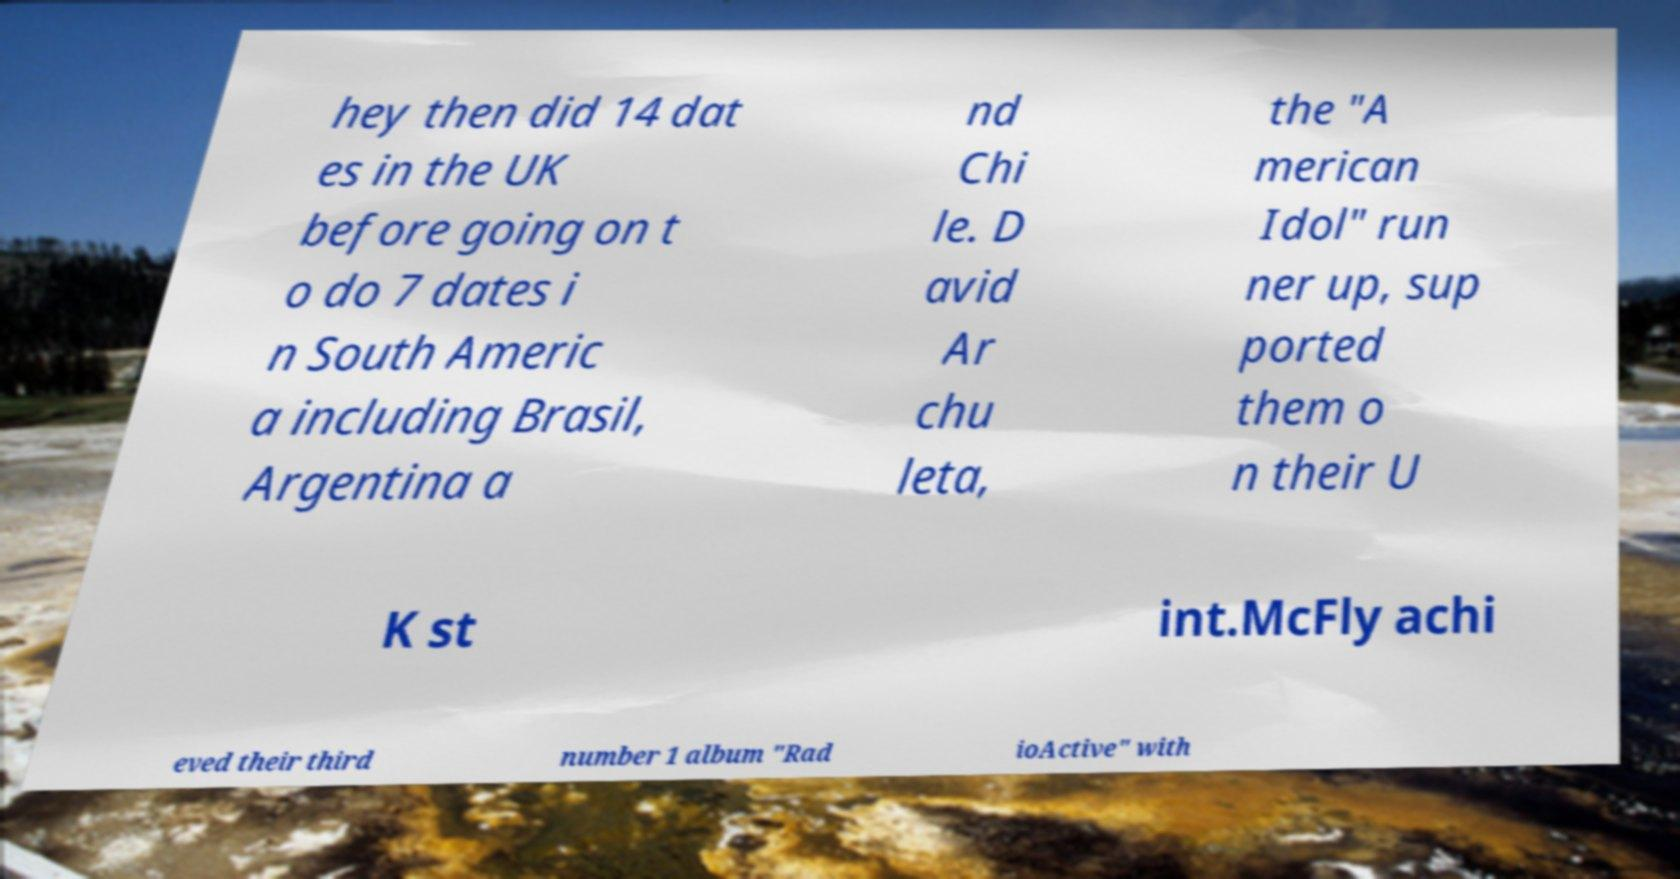Please read and relay the text visible in this image. What does it say? hey then did 14 dat es in the UK before going on t o do 7 dates i n South Americ a including Brasil, Argentina a nd Chi le. D avid Ar chu leta, the "A merican Idol" run ner up, sup ported them o n their U K st int.McFly achi eved their third number 1 album "Rad ioActive" with 